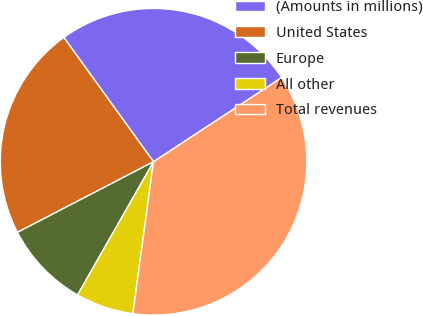Convert chart. <chart><loc_0><loc_0><loc_500><loc_500><pie_chart><fcel>(Amounts in millions)<fcel>United States<fcel>Europe<fcel>All other<fcel>Total revenues<nl><fcel>25.7%<fcel>22.67%<fcel>9.13%<fcel>6.1%<fcel>36.39%<nl></chart> 